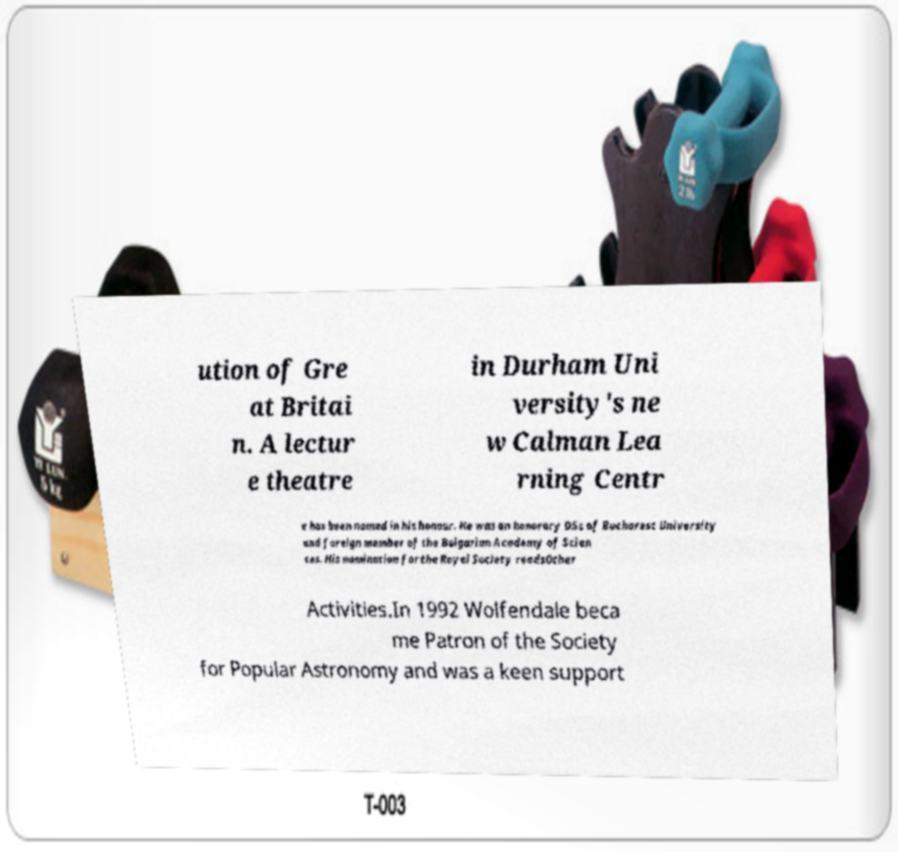Could you extract and type out the text from this image? ution of Gre at Britai n. A lectur e theatre in Durham Uni versity's ne w Calman Lea rning Centr e has been named in his honour. He was an honorary DSc of Bucharest University and foreign member of the Bulgarian Academy of Scien ces. His nomination for the Royal Society readsOther Activities.In 1992 Wolfendale beca me Patron of the Society for Popular Astronomy and was a keen support 